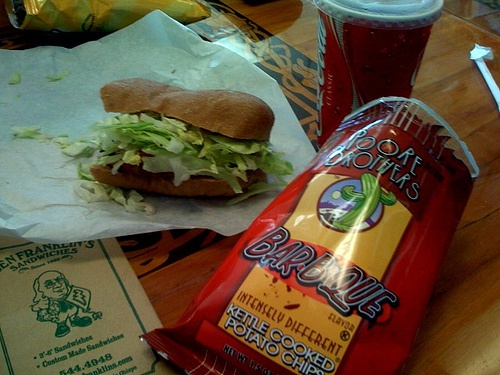Describe the objects in this image and their specific colors. I can see dining table in black, maroon, olive, and gray tones, sandwich in black, olive, gray, and maroon tones, and cup in black, maroon, teal, and gray tones in this image. 